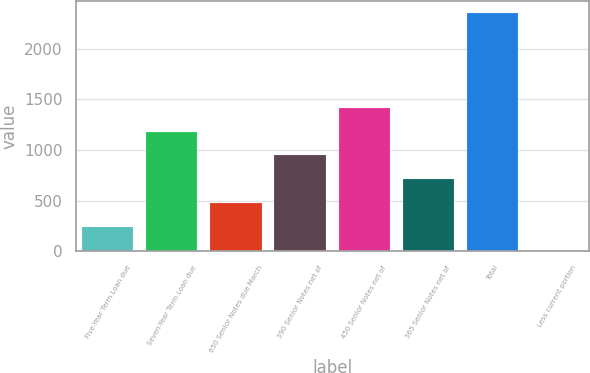<chart> <loc_0><loc_0><loc_500><loc_500><bar_chart><fcel>Five-Year Term Loan due<fcel>Seven-Year Term Loan due<fcel>650 Senior Notes due March<fcel>390 Senior Notes net of<fcel>450 Senior Notes net of<fcel>365 Senior Notes net of<fcel>Total<fcel>Less current portion<nl><fcel>241.39<fcel>1180.95<fcel>476.28<fcel>946.06<fcel>1415.84<fcel>711.17<fcel>2355.4<fcel>6.5<nl></chart> 